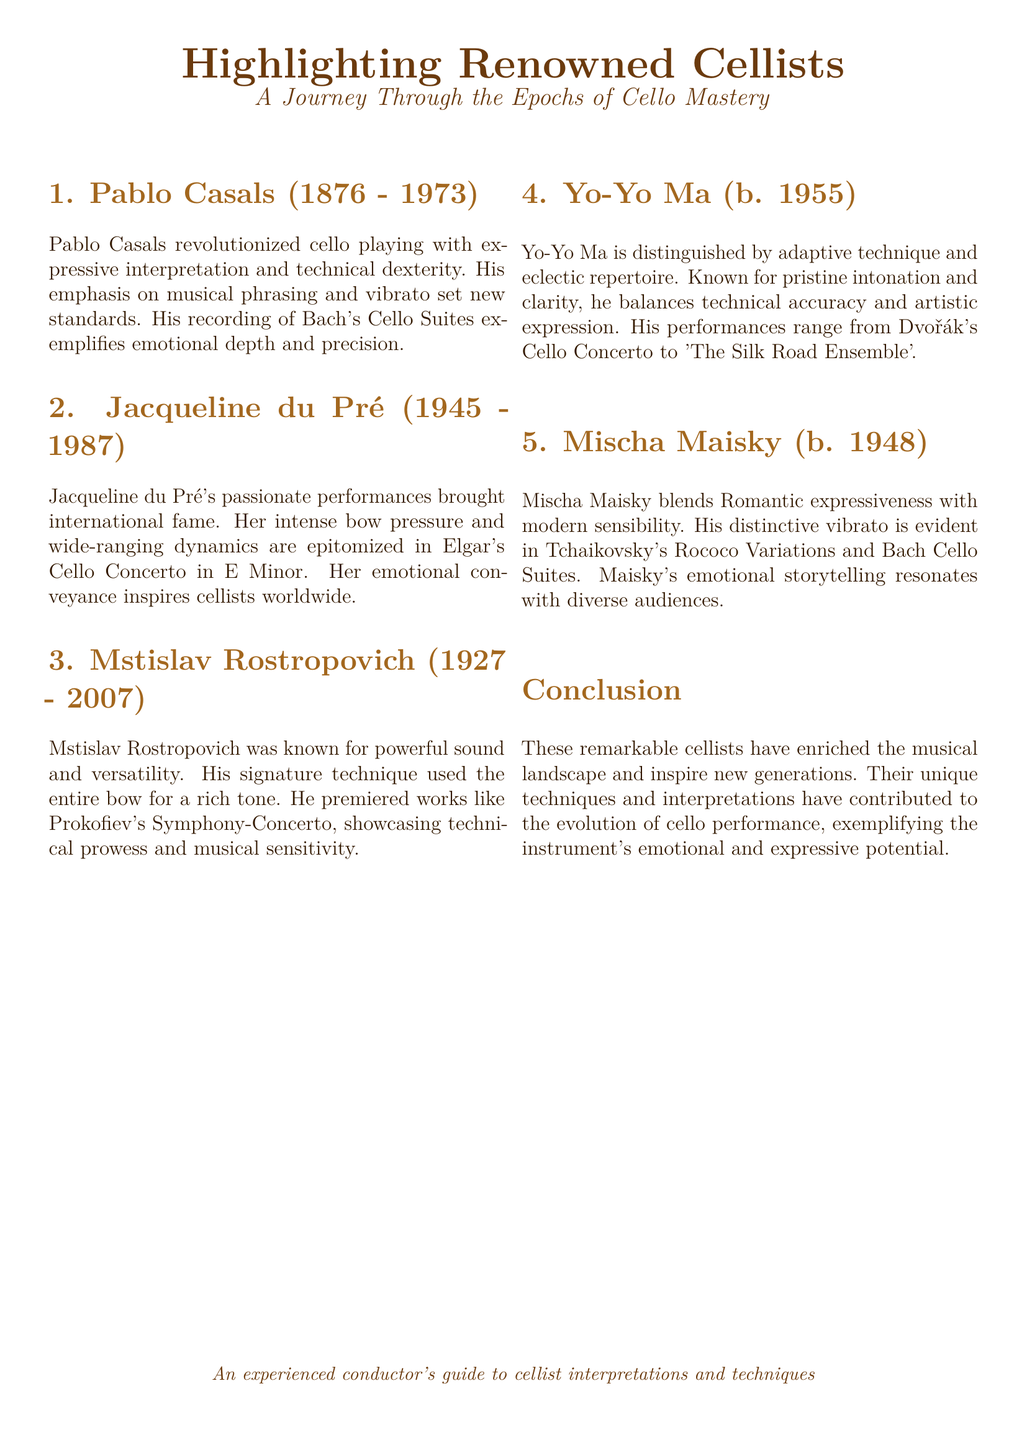What is the birth year of Pablo Casals? The document states that Pablo Casals was born in 1876.
Answer: 1876 Which famous work did Jacqueline du Pré perform? The document mentions that her performance of Elgar's Cello Concerto in E Minor brought her fame.
Answer: Elgar's Cello Concerto in E Minor Who is known for using the entire bow for a rich tone? The document indicates that Mstislav Rostropovich was known for this technique.
Answer: Mstislav Rostropovich What is Yo-Yo Ma's distinguishing feature? The document highlights his adaptive technique and eclectic repertoire as distinguishing features.
Answer: Adaptive technique and eclectic repertoire Which cellist's vibrato is distinctively expressed in Tchaikovsky's Rococo Variations? The document states that Mischa Maisky's distinctive vibrato is evident in these variations.
Answer: Mischa Maisky How many cellists are highlighted in the document? The document lists five renowned cellists in total.
Answer: Five What conclusion is drawn about the highlighted cellists? The document concludes that these cellists have enriched the musical landscape and inspire new generations.
Answer: Enriched the musical landscape What emotional quality is associated with Mischa Maisky's performances? The document describes his performances as resonating with emotional storytelling.
Answer: Emotional storytelling In what year did Jacqueline du Pré pass away? The document states that she passed away in 1987.
Answer: 1987 